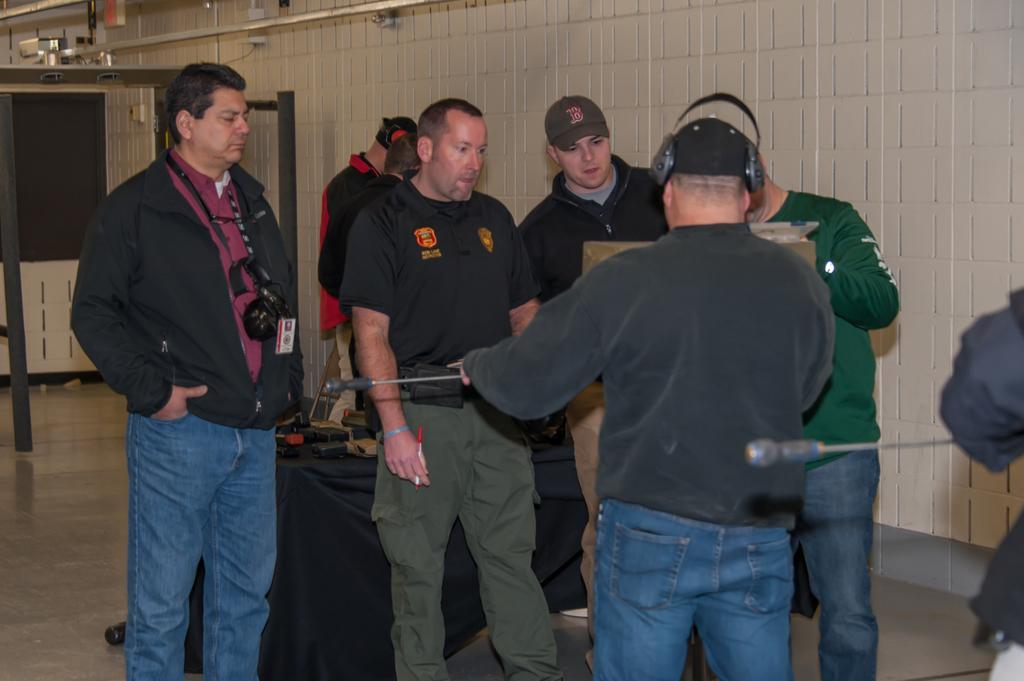In one or two sentences, can you explain what this image depicts? In front of the image there are two people holding some objects. In front of them there are a few other people standing on the floor. There is a table. On top of it there are some objects. In the background of the image there is a wall. There are metal rods. 